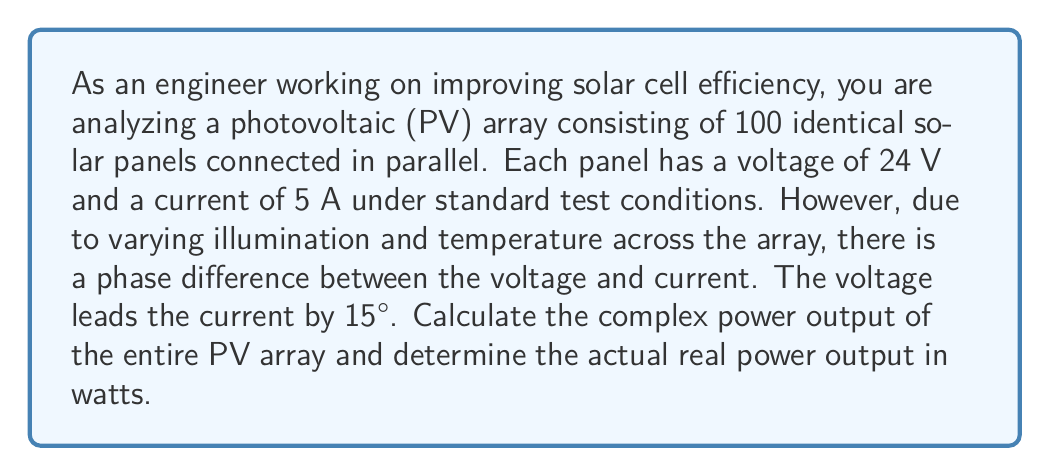Solve this math problem. To solve this problem, we'll use complex number representation for power calculations in AC circuits, which can also be applied to DC systems with phase differences.

1. First, let's define the voltage and current for a single panel:
   Voltage: $V = 24 \angle 15° = 24(\cos 15° + j \sin 15°)$ V
   Current: $I = 5 \angle 0° = 5$ A

2. The complex power for a single panel is given by:
   $$S = VI^* = 24 \angle 15° \cdot 5 \angle 0° = 120 \angle 15° \text{ VA}$$

3. To convert from polar to rectangular form:
   $$S = 120(\cos 15° + j \sin 15°) = 115.93 + j31.05 \text{ VA}$$

4. For 100 panels in parallel, the total complex power is:
   $$S_{\text{total}} = 100S = 100(115.93 + j31.05) = 11,593 + j3,105 \text{ VA}$$

5. The magnitude of the complex power gives us the apparent power:
   $$|S_{\text{total}}| = \sqrt{11,593^2 + 3,105^2} = 12,000 \text{ VA}$$

6. The real power (actual power output) is the real part of the complex power:
   $$P = \text{Re}(S_{\text{total}}) = 11,593 \text{ W}$$
Answer: The complex power output of the entire PV array is $S_{\text{total}} = 11,593 + j3,105 \text{ VA}$, and the actual real power output is 11,593 W or approximately 11.6 kW. 